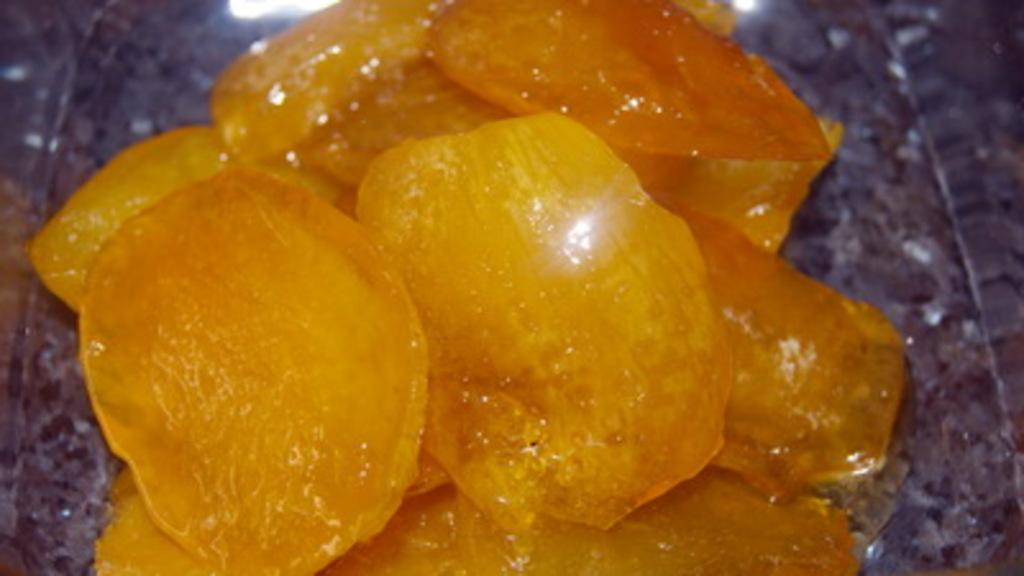What color are the objects in the image? The objects in the image are yellow. Where are the yellow objects located? The objects are on a surface. Are there any ants crawling on the yellow objects in the image? There is no mention of ants in the provided facts, so we cannot determine if there are any ants present in the image. 